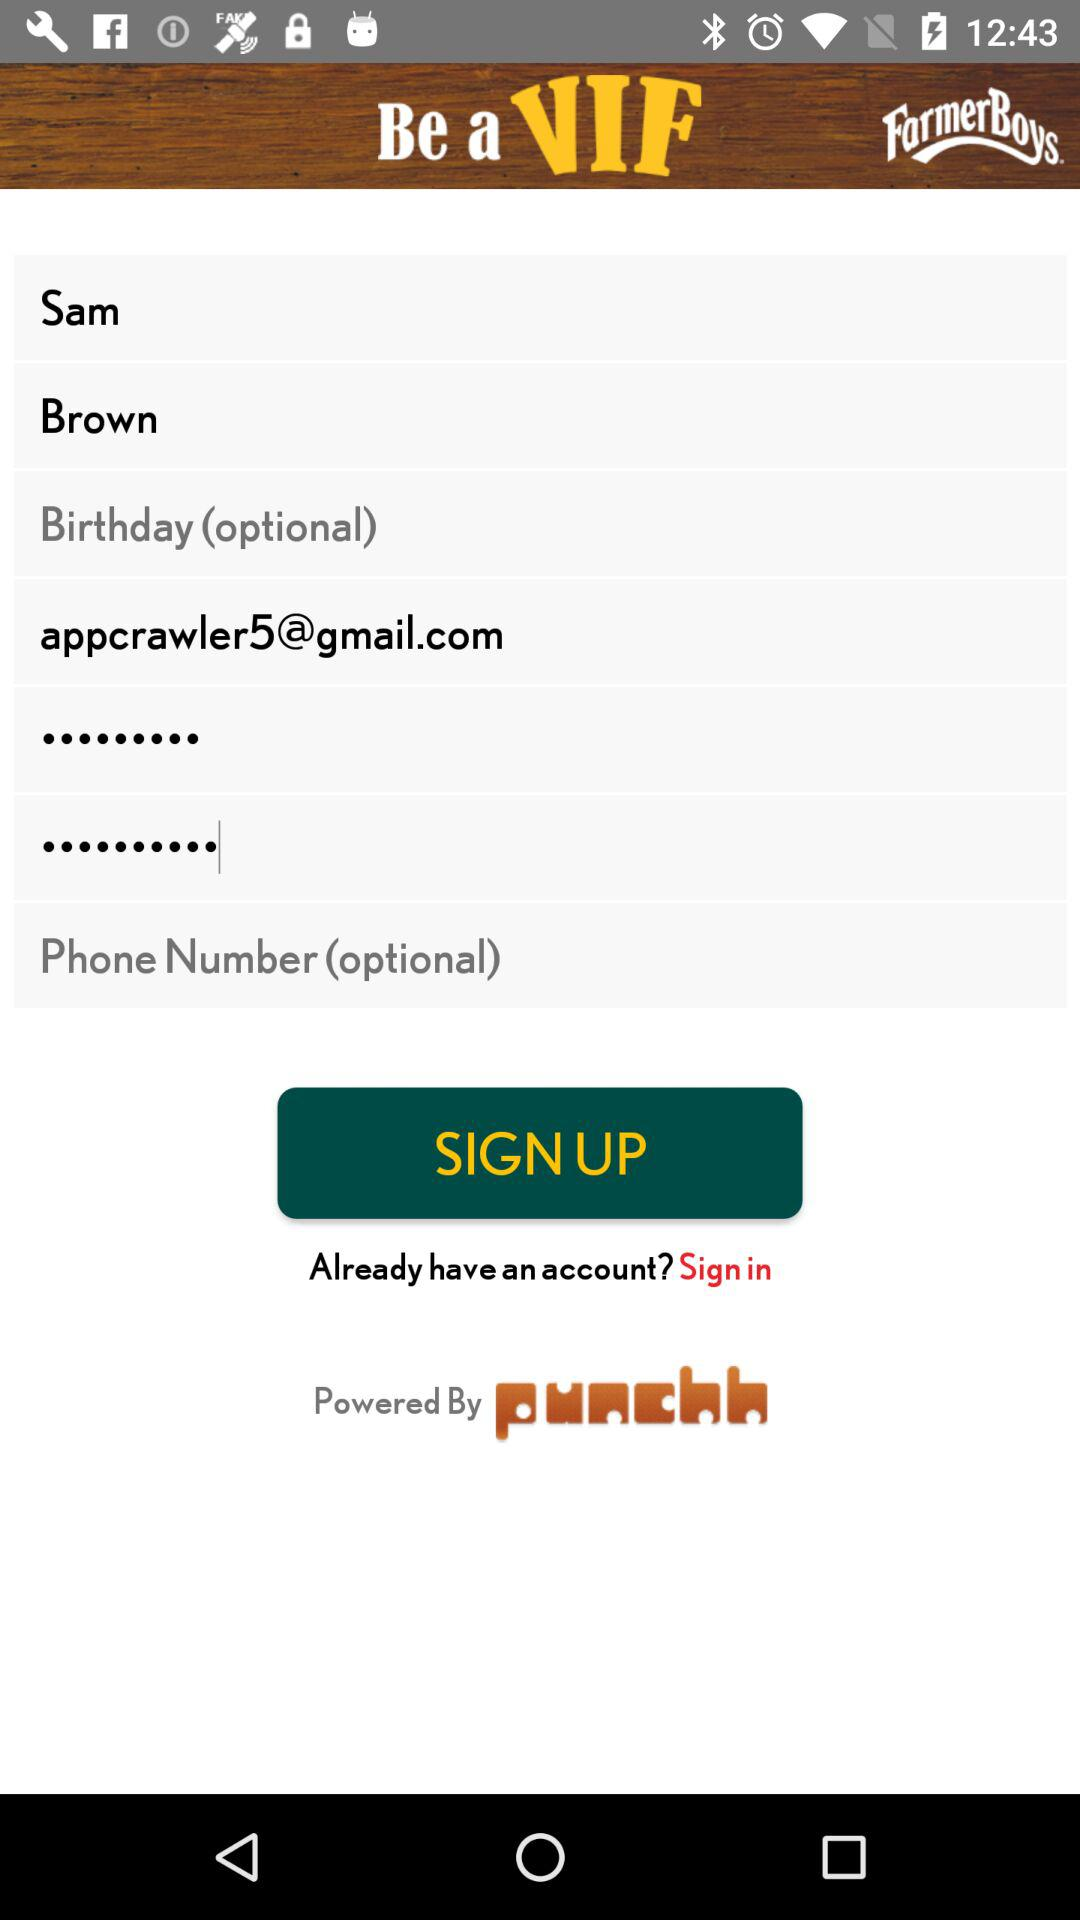Is there phone number given?
When the provided information is insufficient, respond with <no answer>. <no answer> 